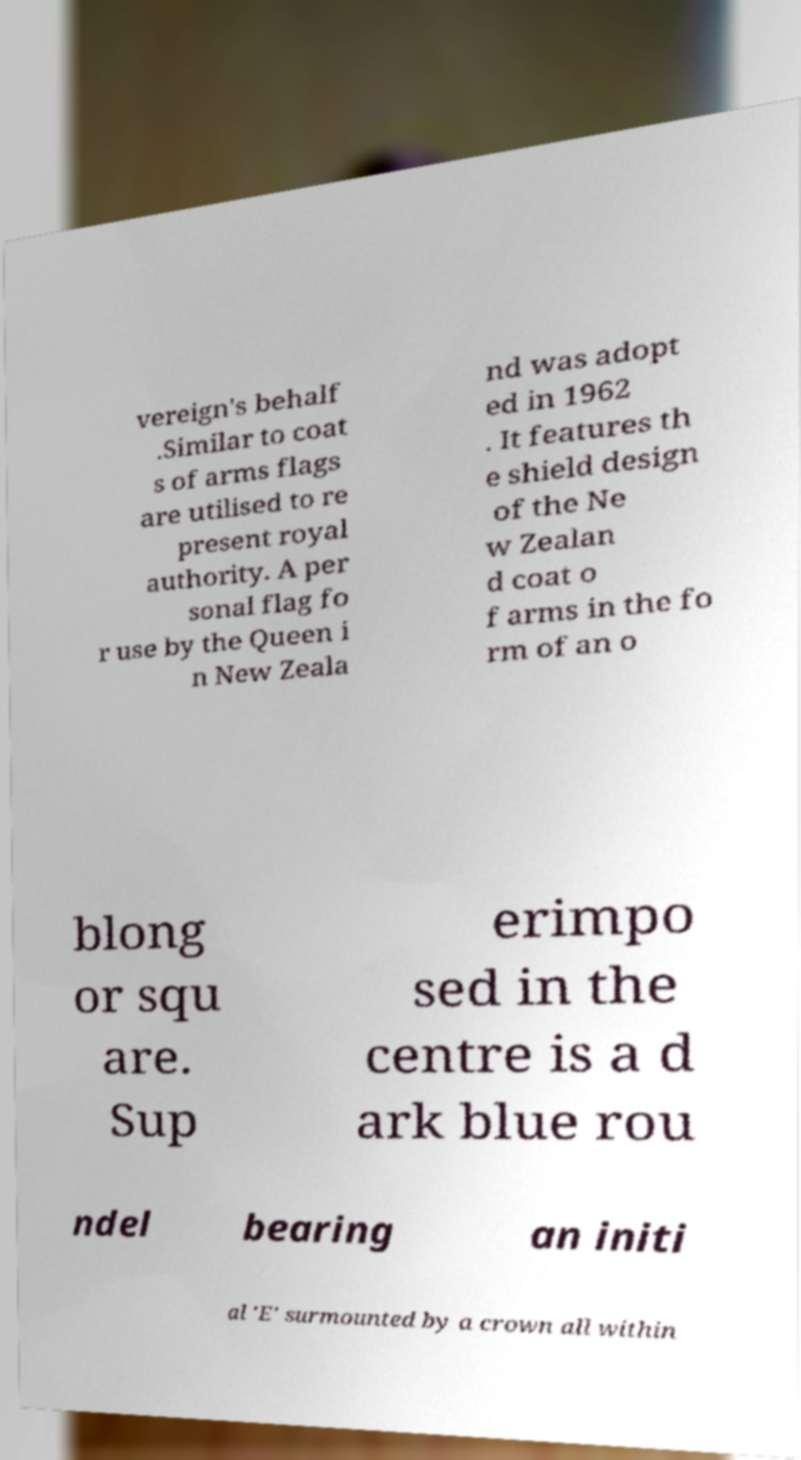Please read and relay the text visible in this image. What does it say? vereign's behalf .Similar to coat s of arms flags are utilised to re present royal authority. A per sonal flag fo r use by the Queen i n New Zeala nd was adopt ed in 1962 . It features th e shield design of the Ne w Zealan d coat o f arms in the fo rm of an o blong or squ are. Sup erimpo sed in the centre is a d ark blue rou ndel bearing an initi al 'E' surmounted by a crown all within 